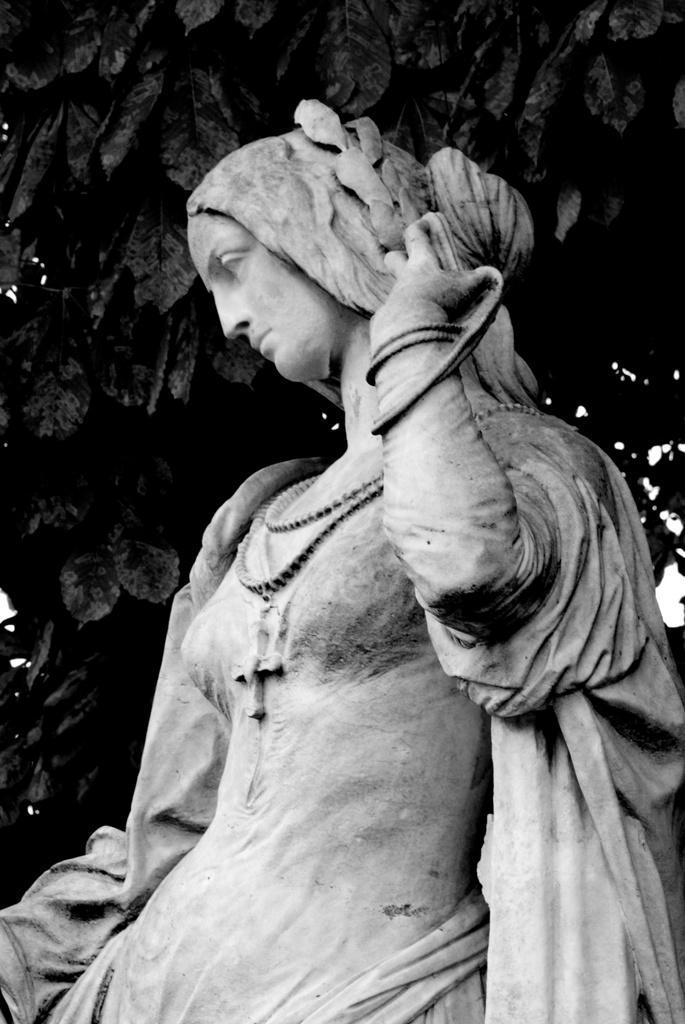How would you summarize this image in a sentence or two? This is a black and white image. I can see a sculpture of a woman. In the background, there are leaves. 